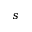<formula> <loc_0><loc_0><loc_500><loc_500>s</formula> 